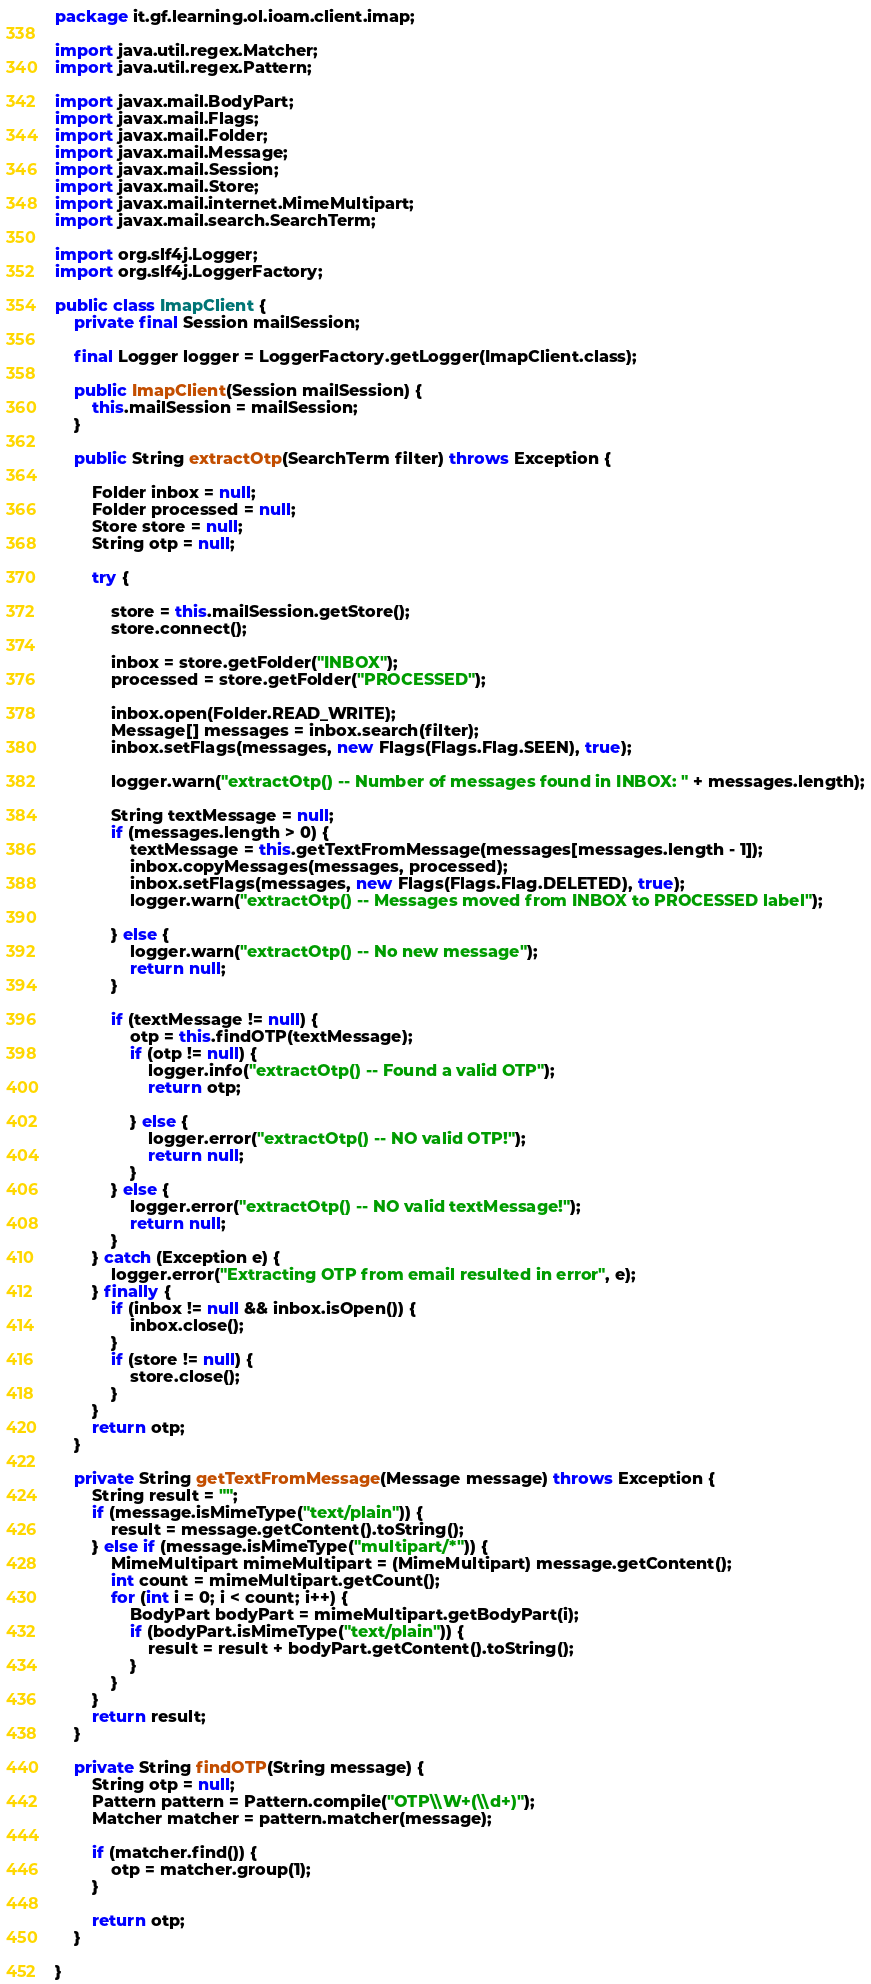Convert code to text. <code><loc_0><loc_0><loc_500><loc_500><_Java_>package it.gf.learning.ol.ioam.client.imap;

import java.util.regex.Matcher;
import java.util.regex.Pattern;

import javax.mail.BodyPart;
import javax.mail.Flags;
import javax.mail.Folder;
import javax.mail.Message;
import javax.mail.Session;
import javax.mail.Store;
import javax.mail.internet.MimeMultipart;
import javax.mail.search.SearchTerm;

import org.slf4j.Logger;
import org.slf4j.LoggerFactory;

public class ImapClient {
	private final Session mailSession;

	final Logger logger = LoggerFactory.getLogger(ImapClient.class);

	public ImapClient(Session mailSession) {
		this.mailSession = mailSession;
	}

	public String extractOtp(SearchTerm filter) throws Exception {

		Folder inbox = null;
		Folder processed = null;
		Store store = null;
		String otp = null;

		try {

			store = this.mailSession.getStore();
			store.connect();

			inbox = store.getFolder("INBOX");
			processed = store.getFolder("PROCESSED");

			inbox.open(Folder.READ_WRITE);
			Message[] messages = inbox.search(filter);
			inbox.setFlags(messages, new Flags(Flags.Flag.SEEN), true);

			logger.warn("extractOtp() -- Number of messages found in INBOX: " + messages.length);

			String textMessage = null;
			if (messages.length > 0) {
				textMessage = this.getTextFromMessage(messages[messages.length - 1]);
				inbox.copyMessages(messages, processed);
				inbox.setFlags(messages, new Flags(Flags.Flag.DELETED), true);
				logger.warn("extractOtp() -- Messages moved from INBOX to PROCESSED label");

			} else {
				logger.warn("extractOtp() -- No new message");
				return null;
			}

			if (textMessage != null) {
				otp = this.findOTP(textMessage);
				if (otp != null) {
					logger.info("extractOtp() -- Found a valid OTP");
					return otp;

				} else {
					logger.error("extractOtp() -- NO valid OTP!");
					return null;
				}
			} else {
				logger.error("extractOtp() -- NO valid textMessage!");
				return null;
			}
		} catch (Exception e) {
			logger.error("Extracting OTP from email resulted in error", e);
		} finally {
			if (inbox != null && inbox.isOpen()) {
				inbox.close();
			}
			if (store != null) {
				store.close();
			}
		}
		return otp;
	}

	private String getTextFromMessage(Message message) throws Exception {
		String result = "";
		if (message.isMimeType("text/plain")) {
			result = message.getContent().toString();
		} else if (message.isMimeType("multipart/*")) {
			MimeMultipart mimeMultipart = (MimeMultipart) message.getContent();
			int count = mimeMultipart.getCount();
			for (int i = 0; i < count; i++) {
				BodyPart bodyPart = mimeMultipart.getBodyPart(i);
				if (bodyPart.isMimeType("text/plain")) {
					result = result + bodyPart.getContent().toString();
				}
			}
		}
		return result;
	}

	private String findOTP(String message) {
		String otp = null;
		Pattern pattern = Pattern.compile("OTP\\W+(\\d+)");
		Matcher matcher = pattern.matcher(message);

		if (matcher.find()) {
			otp = matcher.group(1);
		}

		return otp;
	}

}
</code> 